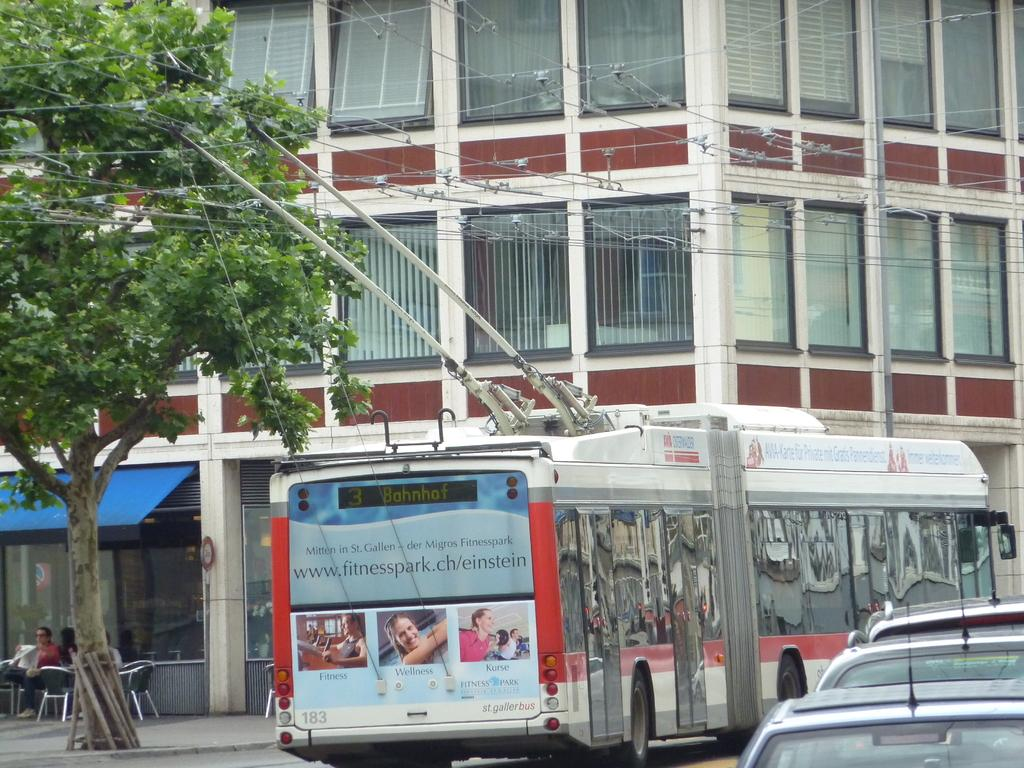What type of structure is present in the image? There is a building in the image. What feature can be seen on the building? The building has windows. What type of furniture is visible in the image? There are chairs in the image. What type of natural element is present in the image? There is a tree in the image. What type of man-made objects are present in the image? Wires and vehicles are visible in the image. What are the people in the image doing? There are people sitting on the chairs. What type of humor can be seen in the image? There is no humor present in the image; it is a scene featuring a building, chairs, a tree, wires, vehicles, and people. Is there a woman in the image? The provided facts do not mention a woman, so we cannot definitively say whether a woman is present in the image. 